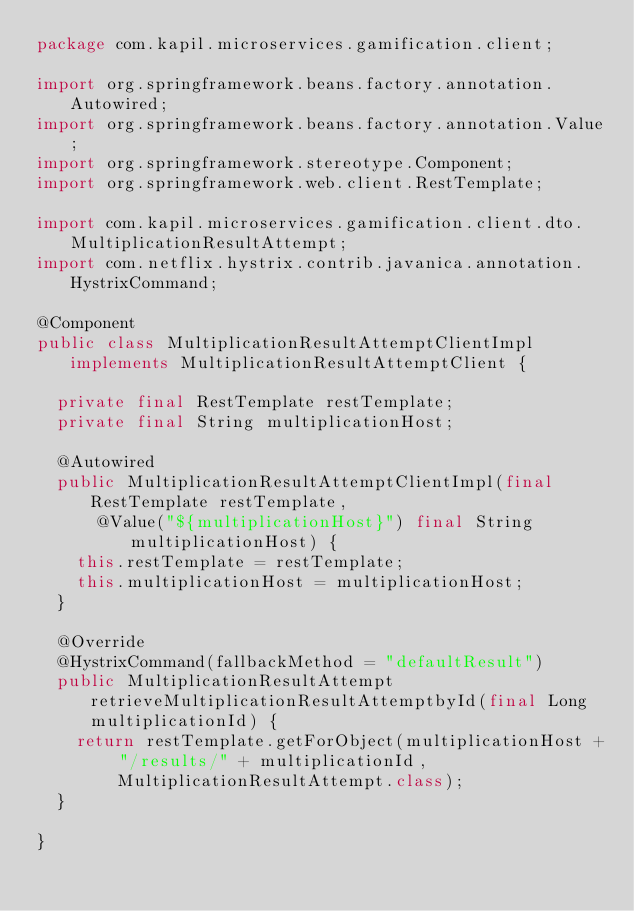Convert code to text. <code><loc_0><loc_0><loc_500><loc_500><_Java_>package com.kapil.microservices.gamification.client;

import org.springframework.beans.factory.annotation.Autowired;
import org.springframework.beans.factory.annotation.Value;
import org.springframework.stereotype.Component;
import org.springframework.web.client.RestTemplate;

import com.kapil.microservices.gamification.client.dto.MultiplicationResultAttempt;
import com.netflix.hystrix.contrib.javanica.annotation.HystrixCommand;

@Component
public class MultiplicationResultAttemptClientImpl implements MultiplicationResultAttemptClient {

	private final RestTemplate restTemplate;
	private final String multiplicationHost;

	@Autowired
	public MultiplicationResultAttemptClientImpl(final RestTemplate restTemplate,
			@Value("${multiplicationHost}") final String multiplicationHost) {
		this.restTemplate = restTemplate;
		this.multiplicationHost = multiplicationHost;
	}

	@Override
	@HystrixCommand(fallbackMethod = "defaultResult")
	public MultiplicationResultAttempt retrieveMultiplicationResultAttemptbyId(final Long multiplicationId) {
		return restTemplate.getForObject(multiplicationHost + "/results/" + multiplicationId,
				MultiplicationResultAttempt.class);
	}

}
</code> 